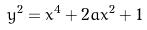<formula> <loc_0><loc_0><loc_500><loc_500>y ^ { 2 } = x ^ { 4 } + 2 a x ^ { 2 } + 1</formula> 